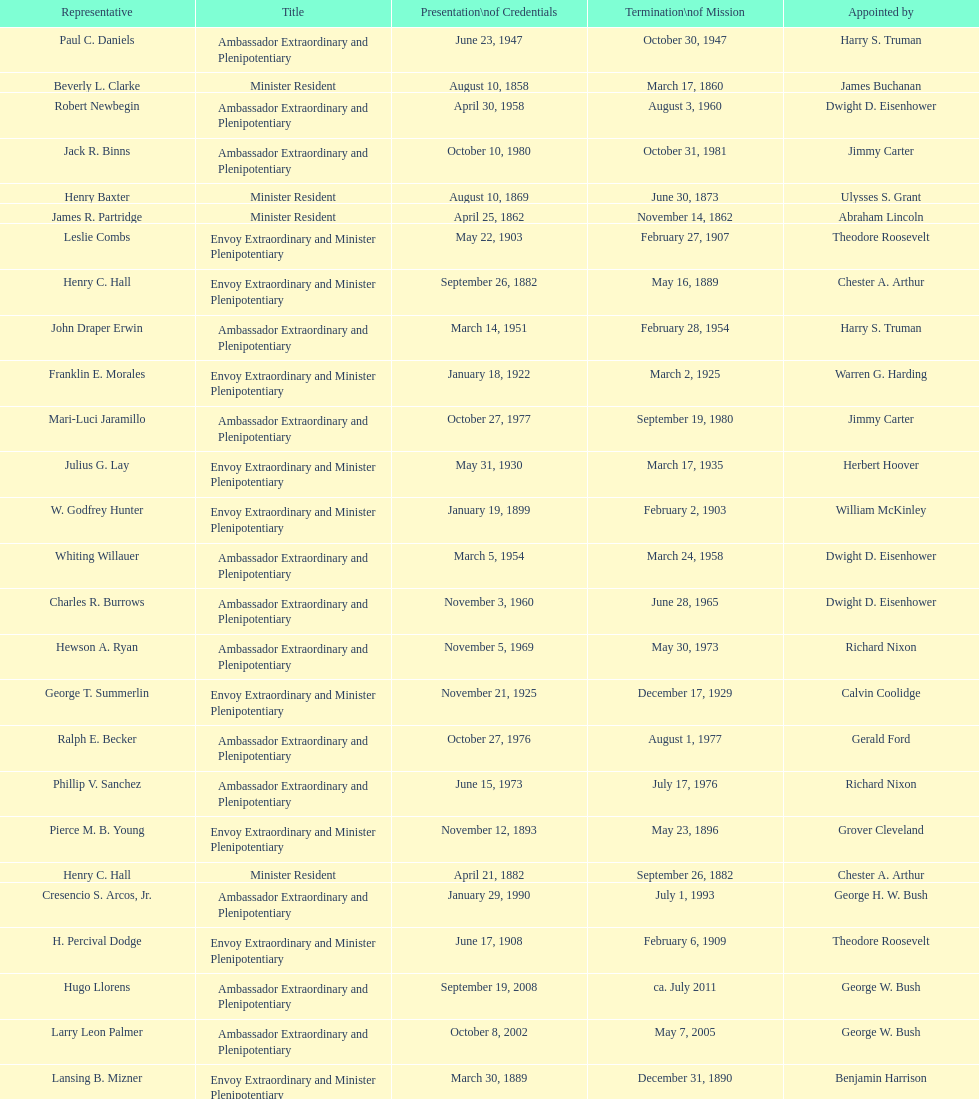Which envoy was the first appointed by woodrow wilson? John Ewing. 